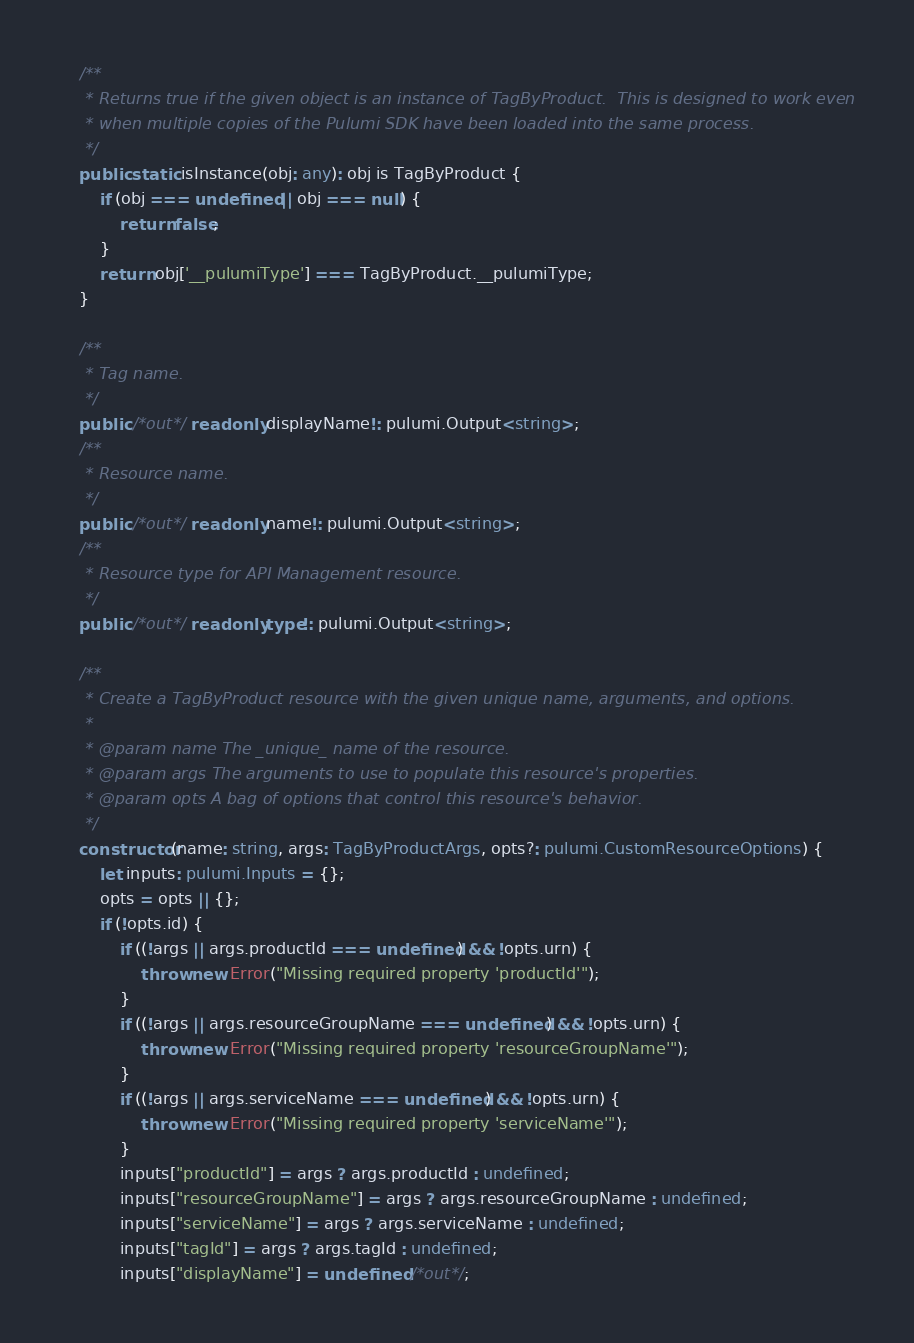<code> <loc_0><loc_0><loc_500><loc_500><_TypeScript_>    /**
     * Returns true if the given object is an instance of TagByProduct.  This is designed to work even
     * when multiple copies of the Pulumi SDK have been loaded into the same process.
     */
    public static isInstance(obj: any): obj is TagByProduct {
        if (obj === undefined || obj === null) {
            return false;
        }
        return obj['__pulumiType'] === TagByProduct.__pulumiType;
    }

    /**
     * Tag name.
     */
    public /*out*/ readonly displayName!: pulumi.Output<string>;
    /**
     * Resource name.
     */
    public /*out*/ readonly name!: pulumi.Output<string>;
    /**
     * Resource type for API Management resource.
     */
    public /*out*/ readonly type!: pulumi.Output<string>;

    /**
     * Create a TagByProduct resource with the given unique name, arguments, and options.
     *
     * @param name The _unique_ name of the resource.
     * @param args The arguments to use to populate this resource's properties.
     * @param opts A bag of options that control this resource's behavior.
     */
    constructor(name: string, args: TagByProductArgs, opts?: pulumi.CustomResourceOptions) {
        let inputs: pulumi.Inputs = {};
        opts = opts || {};
        if (!opts.id) {
            if ((!args || args.productId === undefined) && !opts.urn) {
                throw new Error("Missing required property 'productId'");
            }
            if ((!args || args.resourceGroupName === undefined) && !opts.urn) {
                throw new Error("Missing required property 'resourceGroupName'");
            }
            if ((!args || args.serviceName === undefined) && !opts.urn) {
                throw new Error("Missing required property 'serviceName'");
            }
            inputs["productId"] = args ? args.productId : undefined;
            inputs["resourceGroupName"] = args ? args.resourceGroupName : undefined;
            inputs["serviceName"] = args ? args.serviceName : undefined;
            inputs["tagId"] = args ? args.tagId : undefined;
            inputs["displayName"] = undefined /*out*/;</code> 